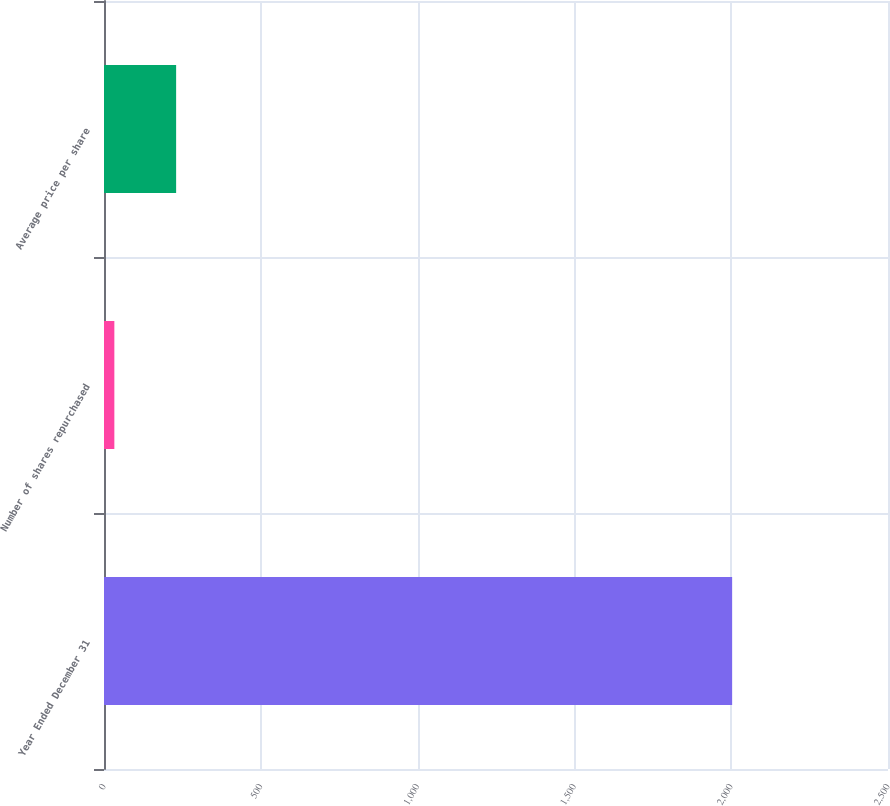Convert chart. <chart><loc_0><loc_0><loc_500><loc_500><bar_chart><fcel>Year Ended December 31<fcel>Number of shares repurchased<fcel>Average price per share<nl><fcel>2003<fcel>33<fcel>230<nl></chart> 